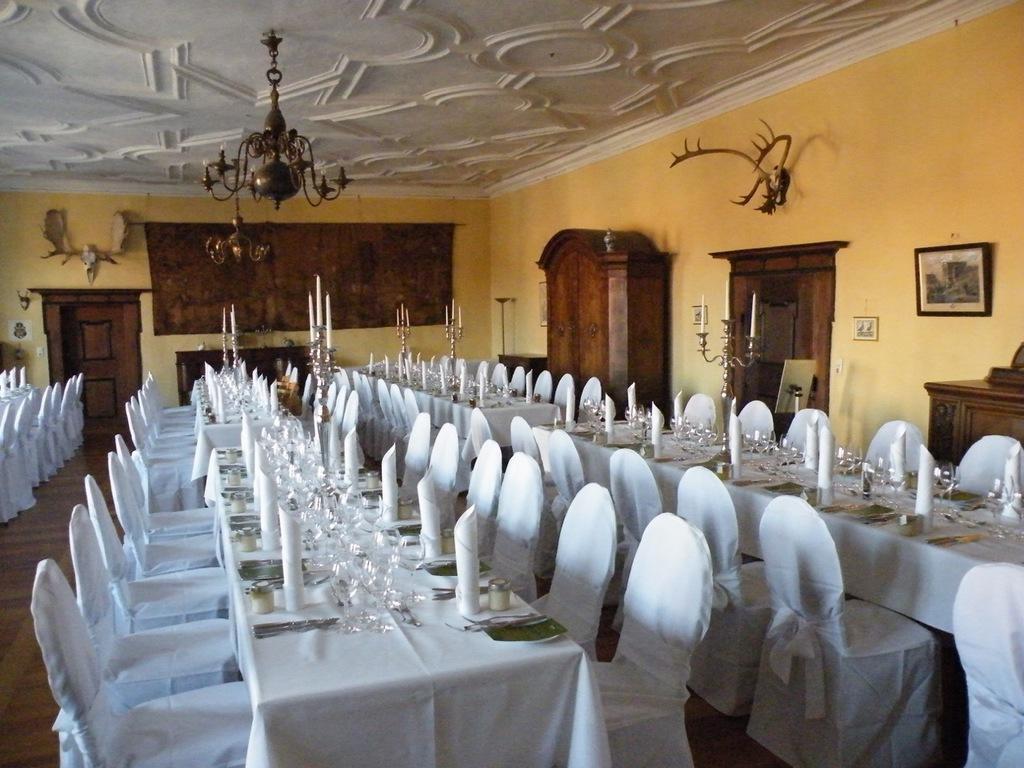How would you summarize this image in a sentence or two? This picture is clicked inside the room. In the foreground we can see the chairs, tables on the top of which glasses, spoons, tissue paper, napkins and candles stands and many other objects are placed. In the background we can see the wall, cabinets containing some items and we can see the picture frame hanging on the wall and we can see the sculptures attached to the wall. At the top there is a roof and the chandeliers hanging on the roof and we can see the door and many other objects. 